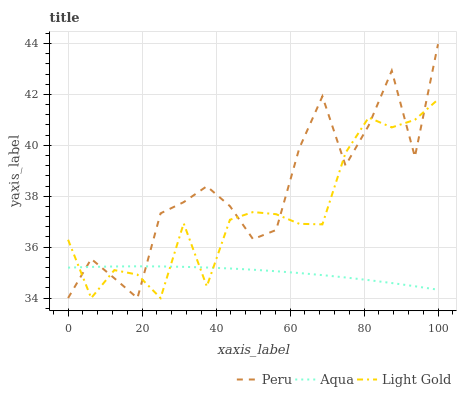Does Aqua have the minimum area under the curve?
Answer yes or no. Yes. Does Peru have the maximum area under the curve?
Answer yes or no. Yes. Does Peru have the minimum area under the curve?
Answer yes or no. No. Does Aqua have the maximum area under the curve?
Answer yes or no. No. Is Aqua the smoothest?
Answer yes or no. Yes. Is Peru the roughest?
Answer yes or no. Yes. Is Peru the smoothest?
Answer yes or no. No. Is Aqua the roughest?
Answer yes or no. No. Does Light Gold have the lowest value?
Answer yes or no. Yes. Does Aqua have the lowest value?
Answer yes or no. No. Does Peru have the highest value?
Answer yes or no. Yes. Does Aqua have the highest value?
Answer yes or no. No. Does Peru intersect Light Gold?
Answer yes or no. Yes. Is Peru less than Light Gold?
Answer yes or no. No. Is Peru greater than Light Gold?
Answer yes or no. No. 